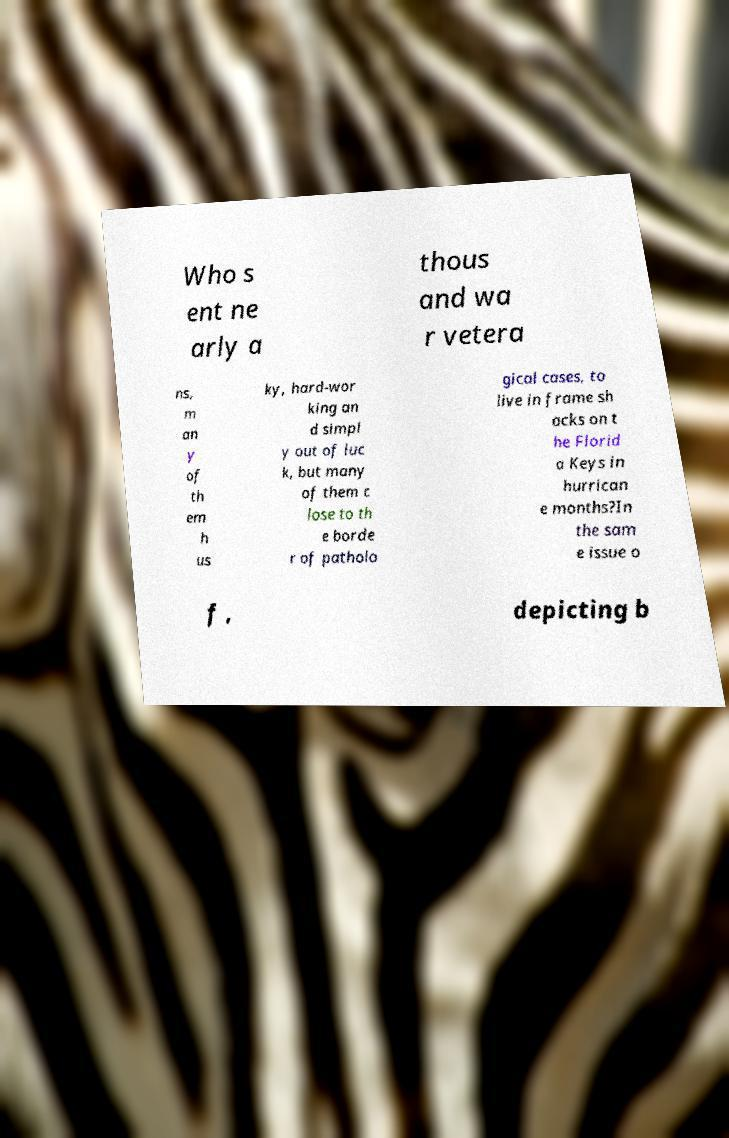What messages or text are displayed in this image? I need them in a readable, typed format. Who s ent ne arly a thous and wa r vetera ns, m an y of th em h us ky, hard-wor king an d simpl y out of luc k, but many of them c lose to th e borde r of patholo gical cases, to live in frame sh acks on t he Florid a Keys in hurrican e months?In the sam e issue o f , depicting b 